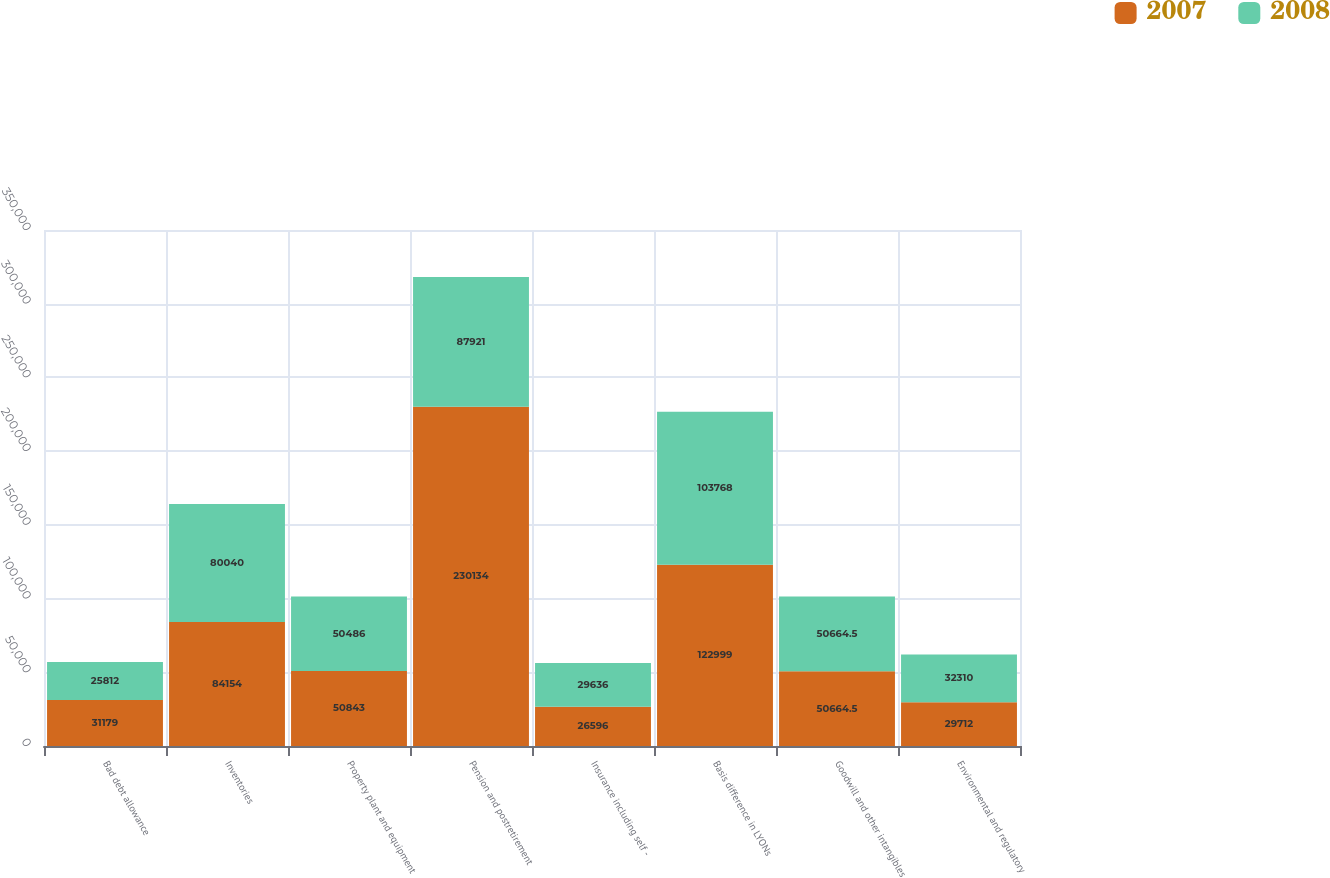Convert chart to OTSL. <chart><loc_0><loc_0><loc_500><loc_500><stacked_bar_chart><ecel><fcel>Bad debt allowance<fcel>Inventories<fcel>Property plant and equipment<fcel>Pension and postretirement<fcel>Insurance including self -<fcel>Basis difference in LYONs<fcel>Goodwill and other intangibles<fcel>Environmental and regulatory<nl><fcel>2007<fcel>31179<fcel>84154<fcel>50843<fcel>230134<fcel>26596<fcel>122999<fcel>50664.5<fcel>29712<nl><fcel>2008<fcel>25812<fcel>80040<fcel>50486<fcel>87921<fcel>29636<fcel>103768<fcel>50664.5<fcel>32310<nl></chart> 